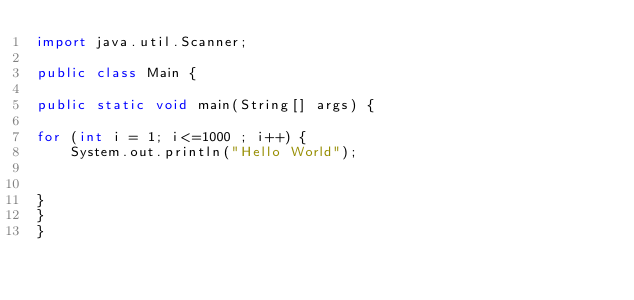Convert code to text. <code><loc_0><loc_0><loc_500><loc_500><_Java_>import java.util.Scanner;

public class Main {

public static void main(String[] args) {

for (int i = 1; i<=1000 ; i++) {
	System.out.println("Hello World");


}
}
}</code> 